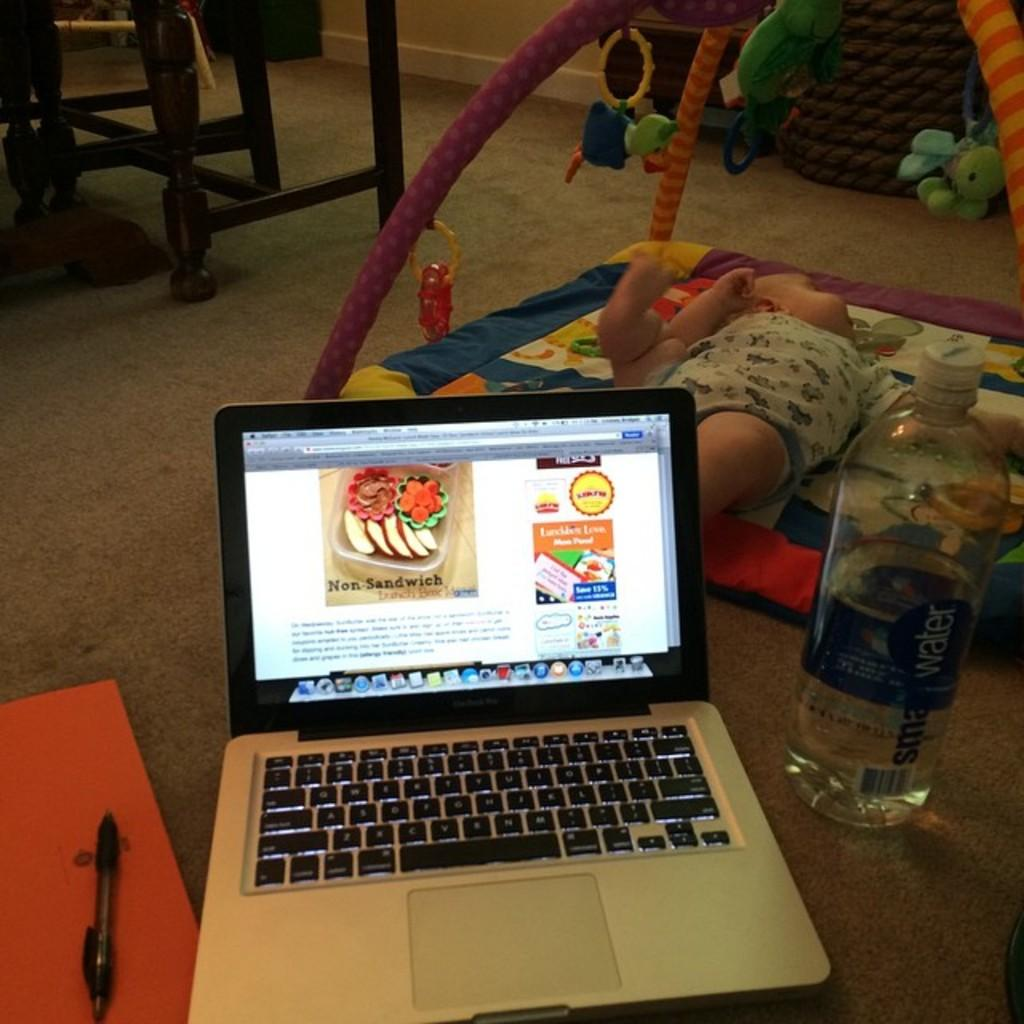What electronic device is visible in the image? There is a laptop in the image. What other objects can be seen in the image? There is a bottle, a pen, toys, and chairs visible in the image. What is the baby doing in the image? The baby is laying on the bed in the image. How many frogs are hopping on the trail in the image? There are no frogs or trails present in the image. 